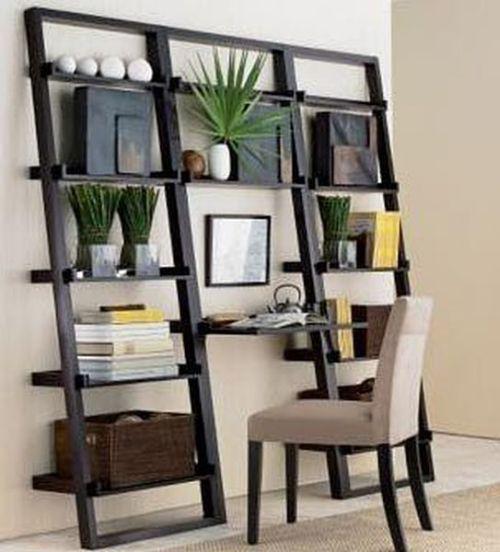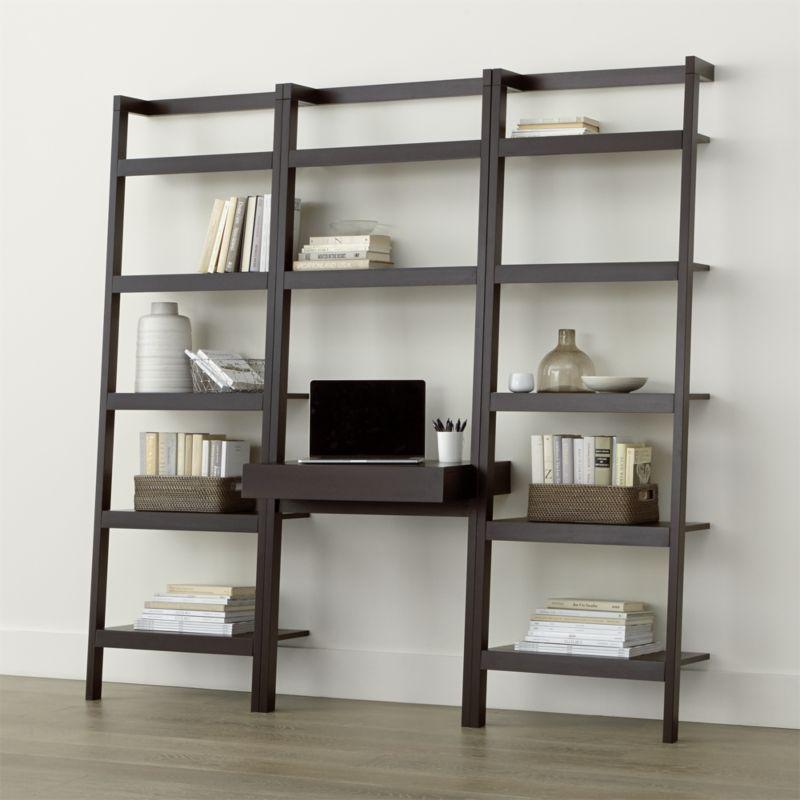The first image is the image on the left, the second image is the image on the right. Given the left and right images, does the statement "there is a herringbone striped rug in front of a wall desk with a white chair with wooden legs" hold true? Answer yes or no. No. 